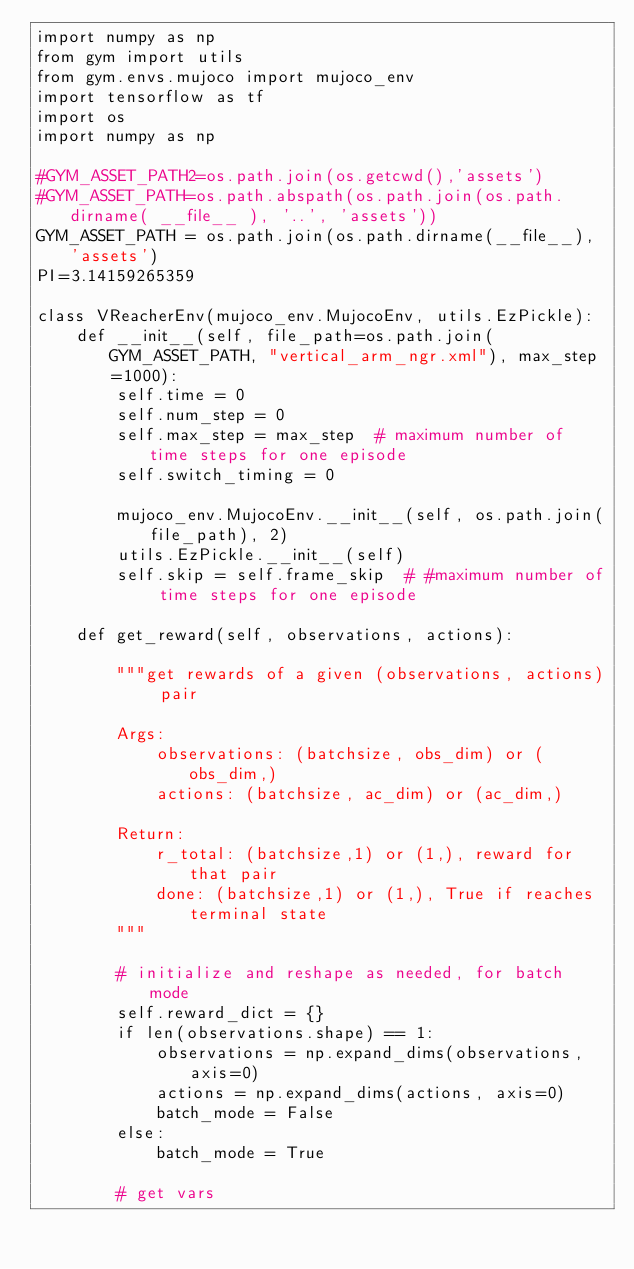Convert code to text. <code><loc_0><loc_0><loc_500><loc_500><_Python_>import numpy as np
from gym import utils
from gym.envs.mujoco import mujoco_env
import tensorflow as tf
import os
import numpy as np

#GYM_ASSET_PATH2=os.path.join(os.getcwd(),'assets')
#GYM_ASSET_PATH=os.path.abspath(os.path.join(os.path.dirname( __file__ ), '..', 'assets'))
GYM_ASSET_PATH = os.path.join(os.path.dirname(__file__), 'assets')
PI=3.14159265359

class VReacherEnv(mujoco_env.MujocoEnv, utils.EzPickle):
    def __init__(self, file_path=os.path.join(GYM_ASSET_PATH, "vertical_arm_ngr.xml"), max_step=1000):
        self.time = 0
        self.num_step = 0
        self.max_step = max_step  # maximum number of time steps for one episode
        self.switch_timing = 0

        mujoco_env.MujocoEnv.__init__(self, os.path.join(file_path), 2)
        utils.EzPickle.__init__(self)
        self.skip = self.frame_skip  # #maximum number of time steps for one episode

    def get_reward(self, observations, actions):

        """get rewards of a given (observations, actions) pair

        Args:
            observations: (batchsize, obs_dim) or (obs_dim,)
            actions: (batchsize, ac_dim) or (ac_dim,)

        Return:
            r_total: (batchsize,1) or (1,), reward for that pair
            done: (batchsize,1) or (1,), True if reaches terminal state
        """

        # initialize and reshape as needed, for batch mode
        self.reward_dict = {}
        if len(observations.shape) == 1:
            observations = np.expand_dims(observations, axis=0)
            actions = np.expand_dims(actions, axis=0)
            batch_mode = False
        else:
            batch_mode = True

        # get vars</code> 